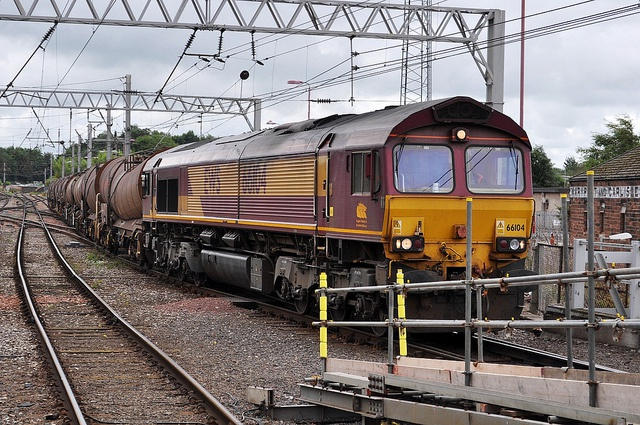Describe the objects in this image and their specific colors. I can see a train in darkgray, black, gray, and maroon tones in this image. 